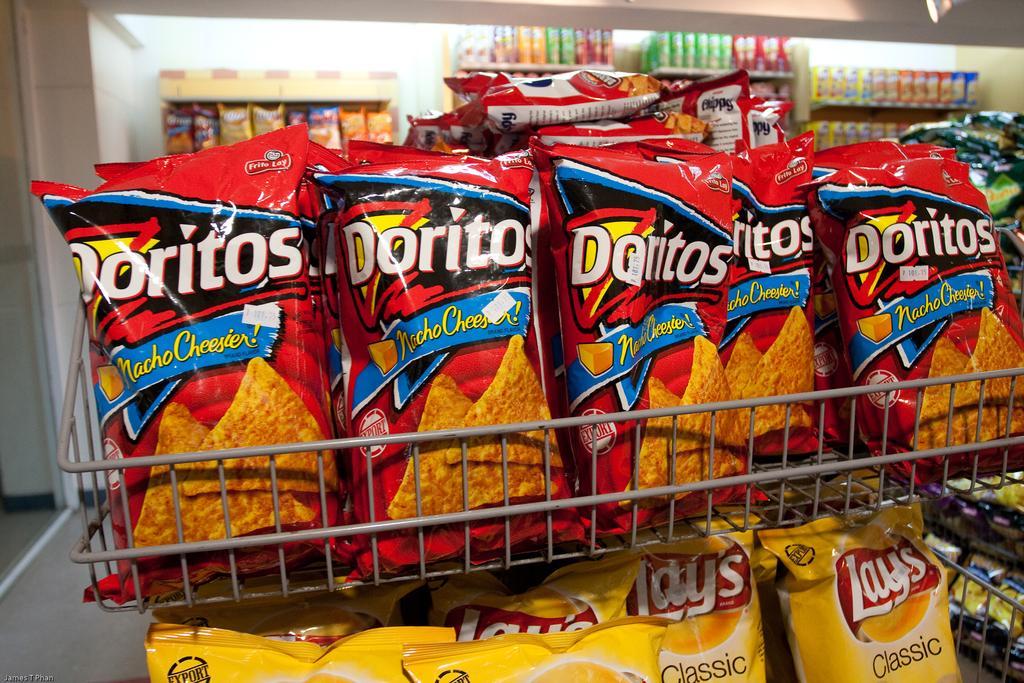Could you give a brief overview of what you see in this image? In this image, I can see the chips packets, which are kept in the racks. This is the wall. At the bottom left corner of the image, I can see the watermark. This looks like the floor. 